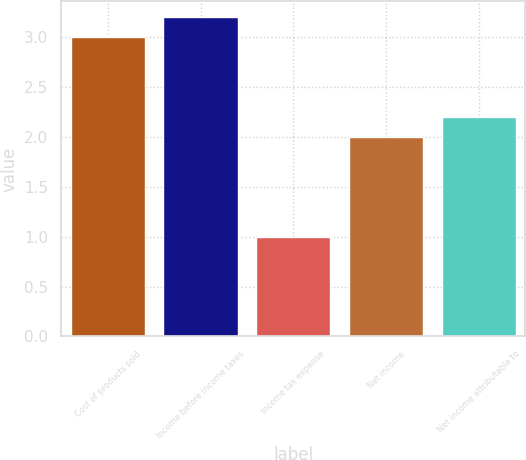<chart> <loc_0><loc_0><loc_500><loc_500><bar_chart><fcel>Cost of products sold<fcel>Income before income taxes<fcel>Income tax expense<fcel>Net income<fcel>Net income attributable to<nl><fcel>3<fcel>3.2<fcel>1<fcel>2<fcel>2.2<nl></chart> 